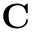<formula> <loc_0><loc_0><loc_500><loc_500>C</formula> 